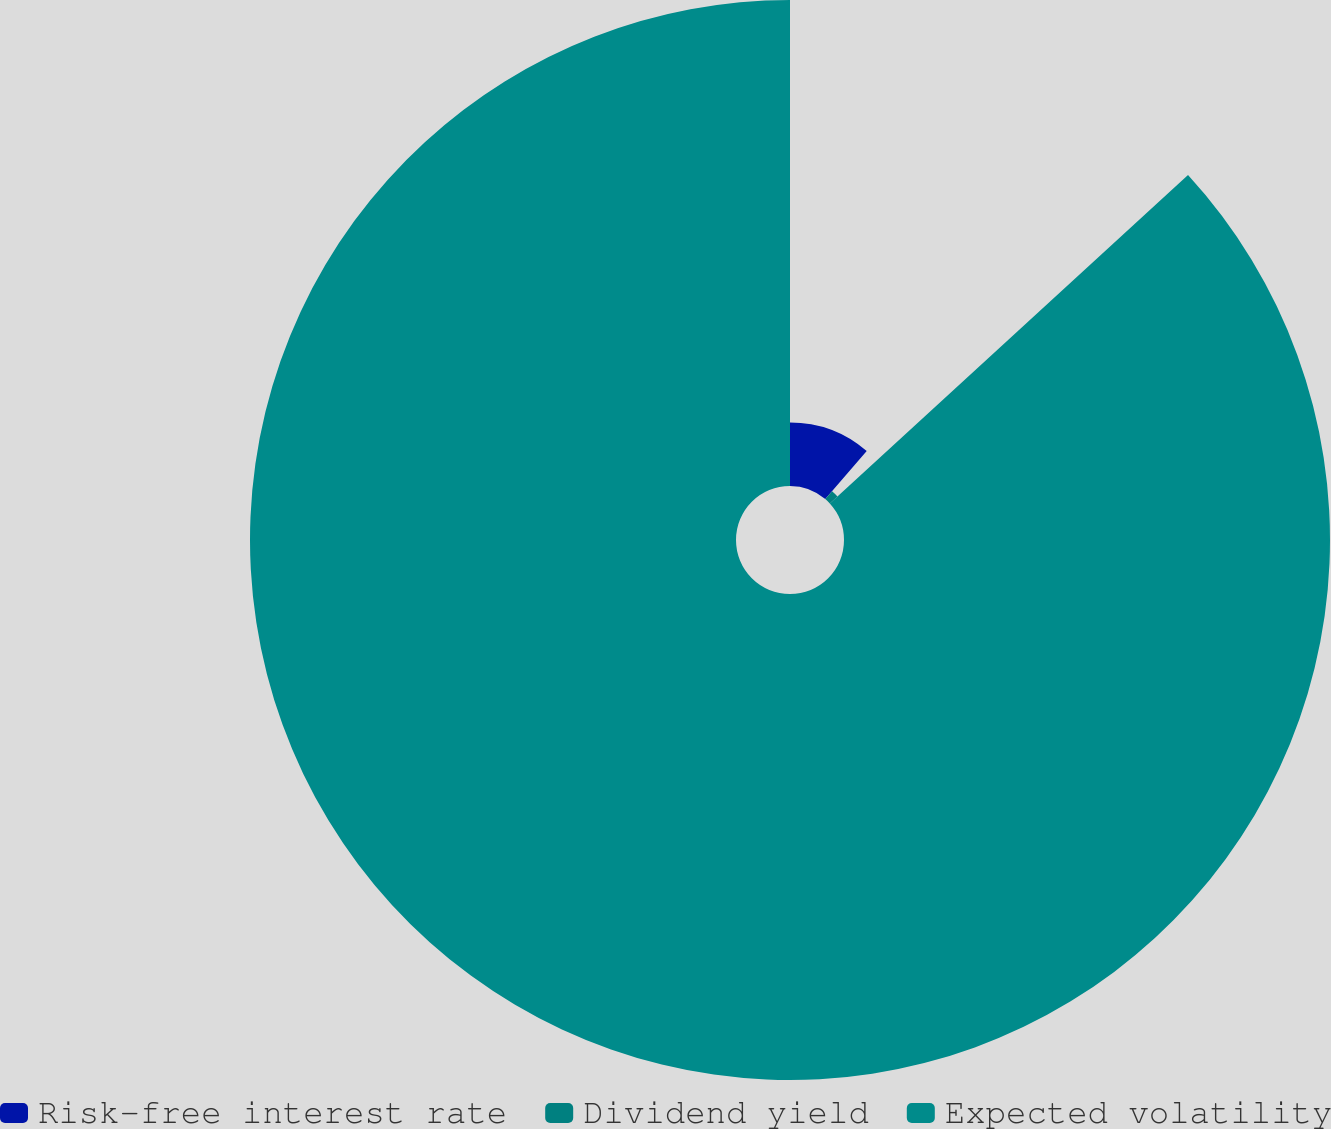<chart> <loc_0><loc_0><loc_500><loc_500><pie_chart><fcel>Risk-free interest rate<fcel>Dividend yield<fcel>Expected volatility<nl><fcel>11.33%<fcel>1.86%<fcel>86.81%<nl></chart> 